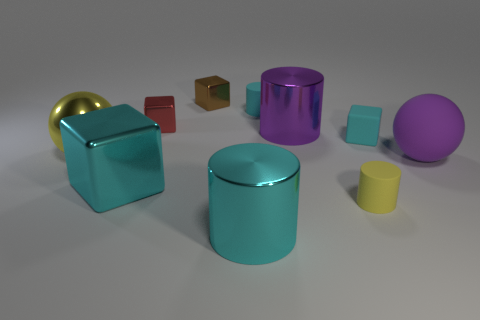Subtract 2 blocks. How many blocks are left? 2 Subtract all yellow balls. Subtract all green blocks. How many balls are left? 1 Subtract all green cylinders. How many cyan spheres are left? 0 Subtract all tiny rubber cylinders. Subtract all big things. How many objects are left? 3 Add 9 yellow cylinders. How many yellow cylinders are left? 10 Add 5 red metal objects. How many red metal objects exist? 6 Subtract all purple spheres. How many spheres are left? 1 Subtract all cyan shiny cylinders. How many cylinders are left? 3 Subtract 0 purple blocks. How many objects are left? 10 Subtract all cubes. How many objects are left? 6 